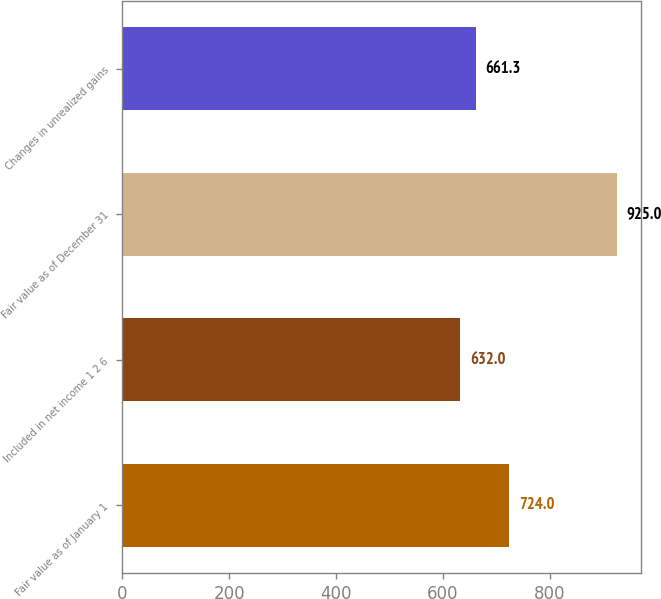Convert chart to OTSL. <chart><loc_0><loc_0><loc_500><loc_500><bar_chart><fcel>Fair value as of January 1<fcel>Included in net income 1 2 6<fcel>Fair value as of December 31<fcel>Changes in unrealized gains<nl><fcel>724<fcel>632<fcel>925<fcel>661.3<nl></chart> 